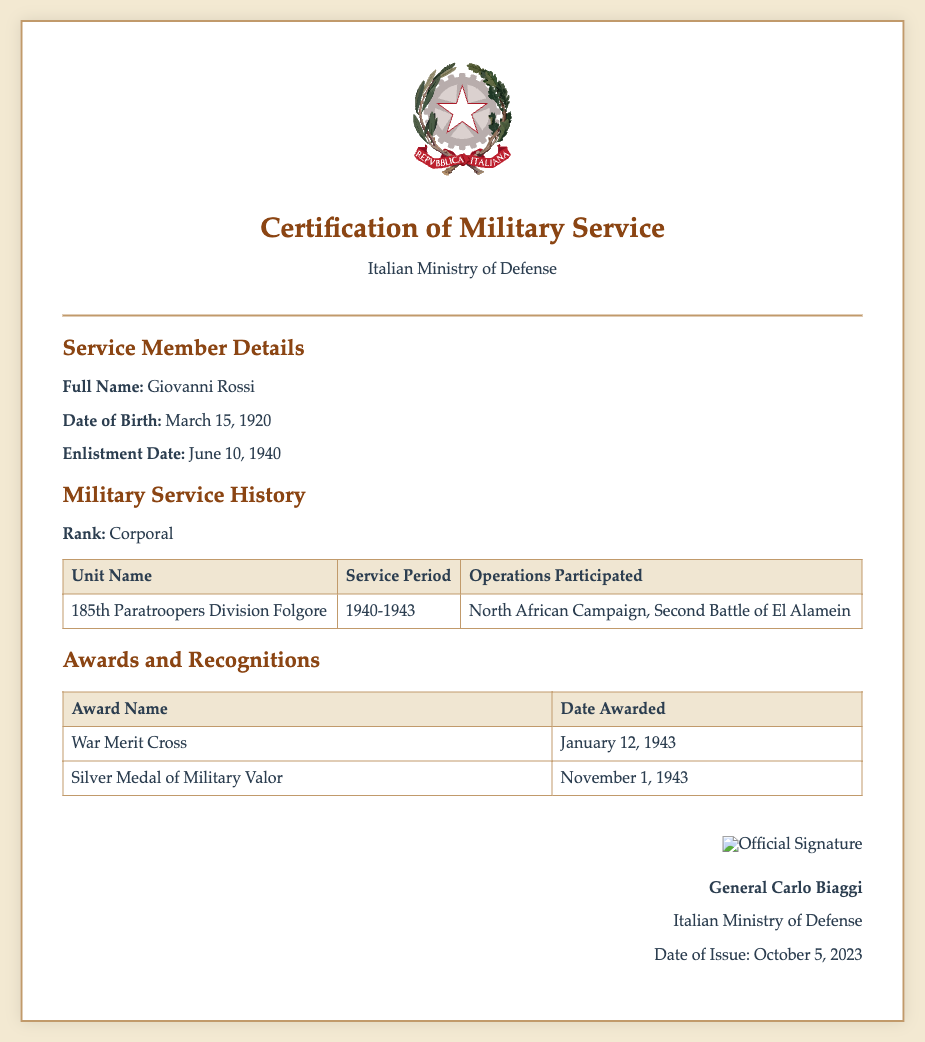What is the full name of the service member? The full name of the service member is stated at the beginning of the document under Service Member Details.
Answer: Giovanni Rossi What is the rank of Giovanni Rossi? The rank is provided in the Military Service History section of the document.
Answer: Corporal When was Giovanni Rossi enlisted? The enlistment date is specified in the Service Member Details section.
Answer: June 10, 1940 Which unit did Giovanni Rossi serve with? The unit name is listed in the Military Service History section under the relevant table.
Answer: 185th Paratroopers Division Folgore What campaign did Giovanni Rossi participate in? The operations participated in are mentioned in the Military Service History section for his unit.
Answer: North African Campaign How many awards did Giovanni Rossi receive? The number of awards can be counted from the Awards and Recognitions section of the document.
Answer: 2 What is the date of issue for this certification? The date of issue is located at the bottom of the document in the signature section.
Answer: October 5, 2023 Who authenticated the document? The person who authenticated the document is named at the bottom of the document.
Answer: General Carlo Biaggi What award was given on January 12, 1943? The specific award is mentioned in the Awards and Recognitions section and includes the date awarded.
Answer: War Merit Cross 